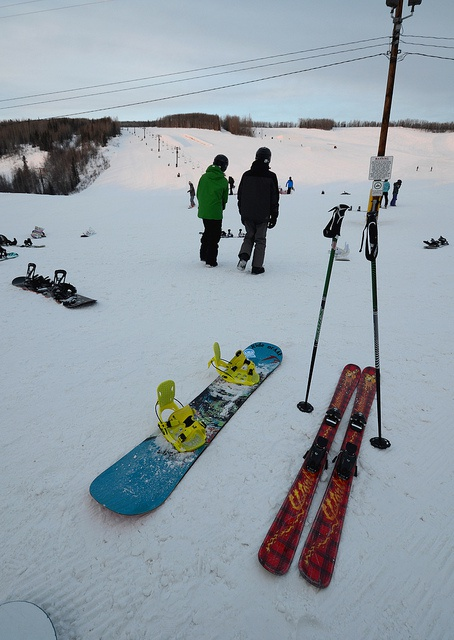Describe the objects in this image and their specific colors. I can see snowboard in darkgray, blue, gray, and black tones, skis in darkgray, maroon, black, and gray tones, people in darkgray, black, gray, and lightgray tones, people in darkgray, black, darkgreen, and lightgray tones, and snowboard in darkgray, black, gray, and darkblue tones in this image. 